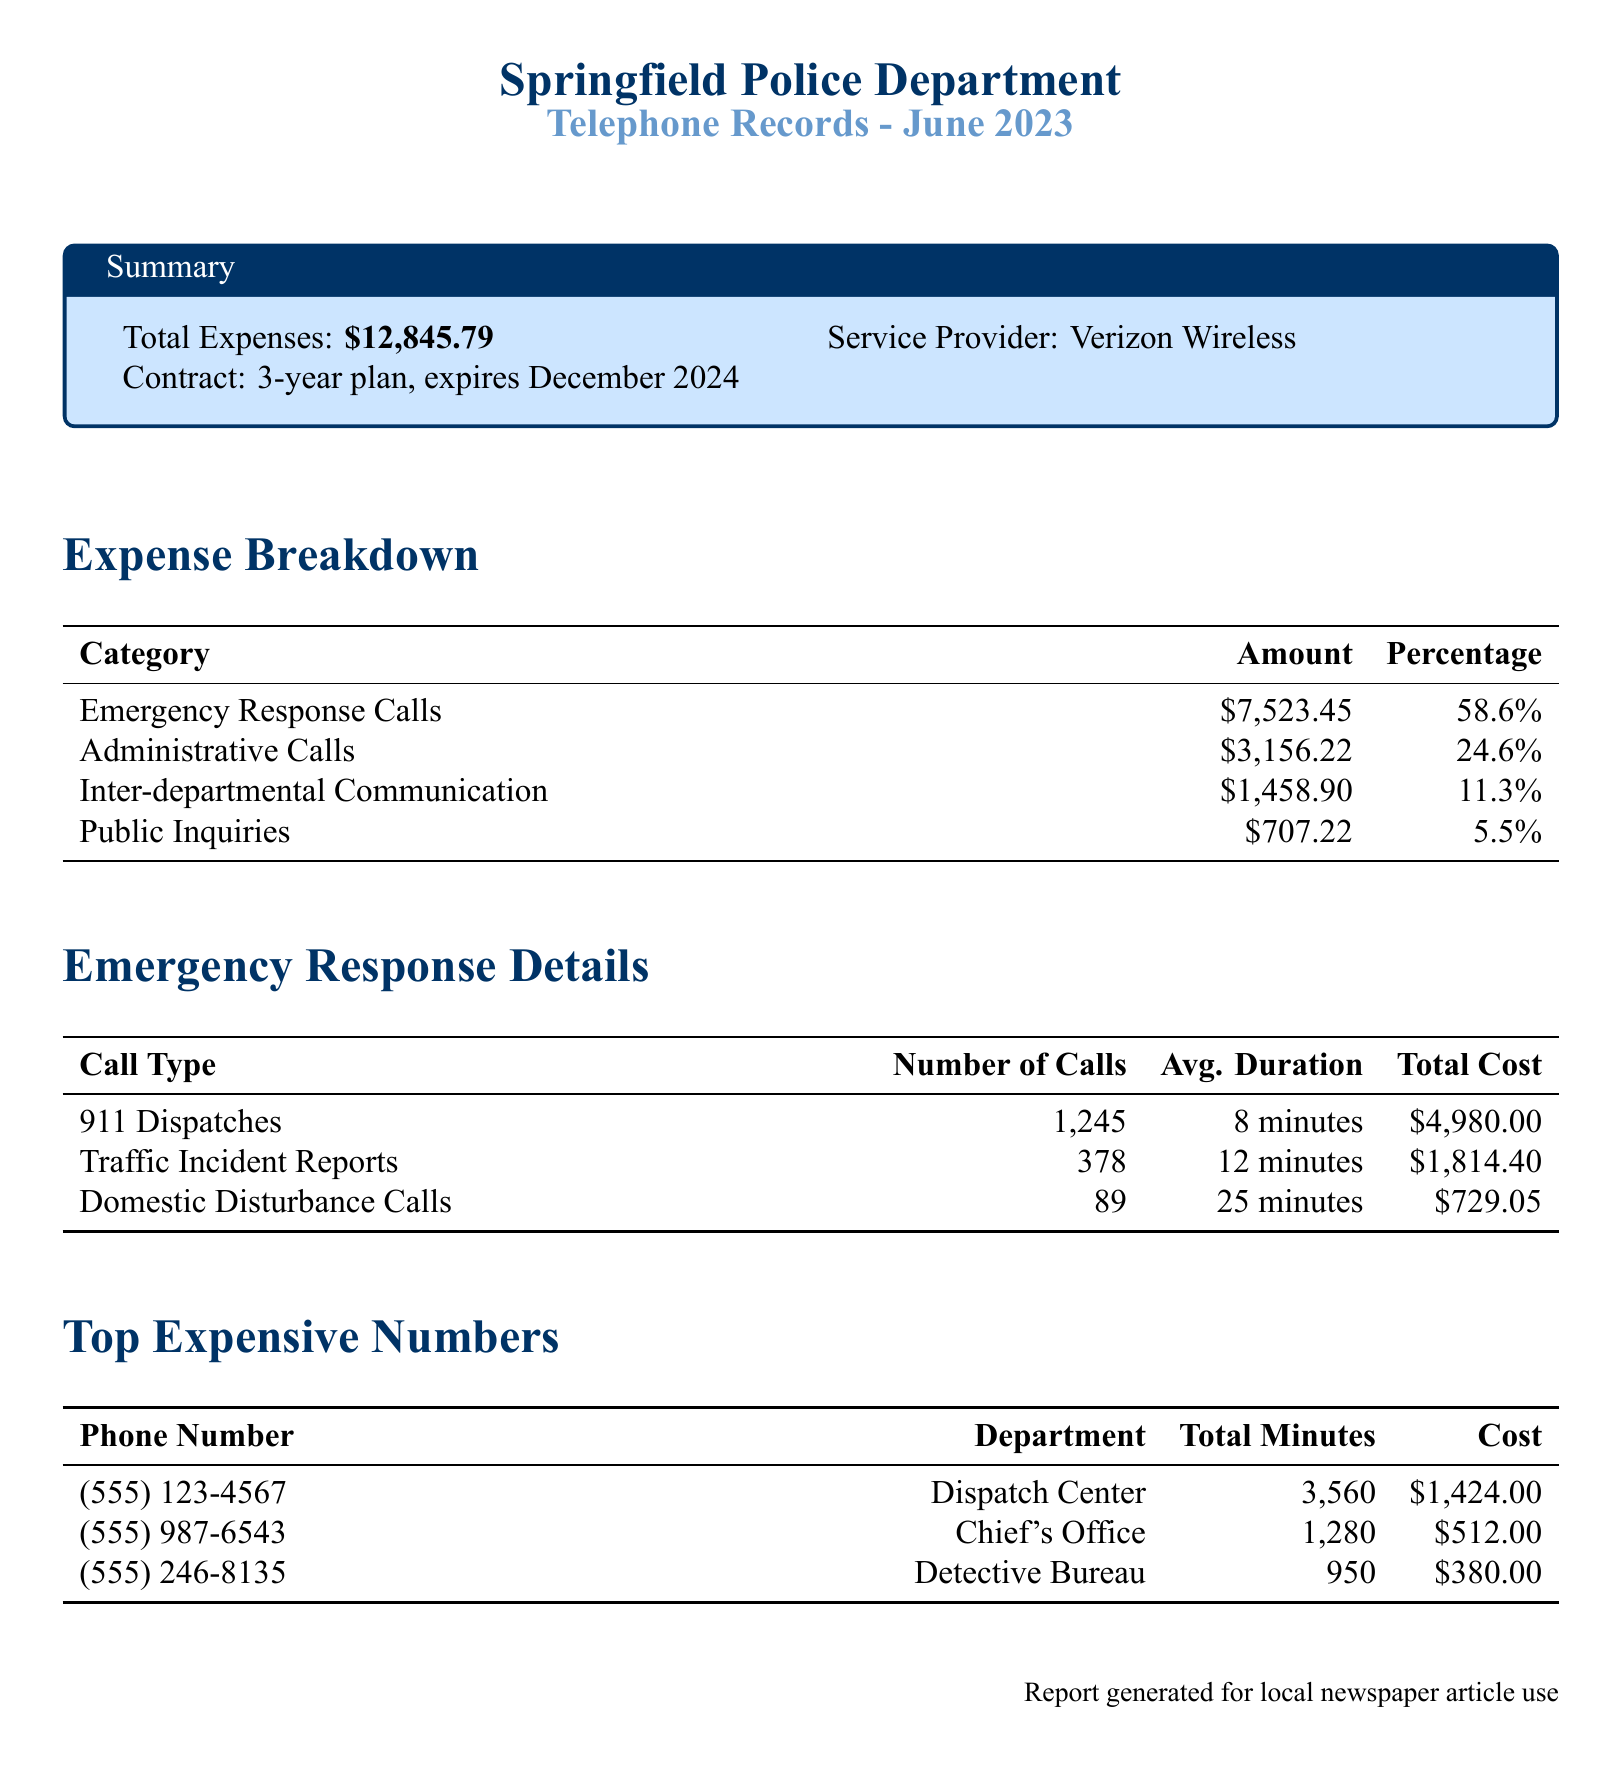What is the total expense for the month? The total expense is listed in the summary section, which is $12,845.79.
Answer: $12,845.79 What percentage of the total expenses are from emergency response calls? The percentage for emergency response calls is calculated in the expense breakdown, which states 58.6%.
Answer: 58.6% How many 911 dispatches were recorded? The number of 911 dispatches is provided in the emergency response details, which is 1,245 calls.
Answer: 1,245 What was the average duration of a traffic incident report call? The average duration for traffic incident report calls is mentioned in the emergency response details, which is 12 minutes.
Answer: 12 minutes Which department had the highest phone cost? The department with the highest phone cost can be identified from the top expensive numbers table, which is the Dispatch Center.
Answer: Dispatch Center What is the total cost for domestic disturbance calls? The total cost for domestic disturbance calls is detailed in the emergency response details, which is $729.05.
Answer: $729.05 What is the service provider for the police department's telephone records? The service provider is listed in the summary section, which is Verizon Wireless.
Answer: Verizon Wireless How many administrative calls were made? The total amount of administrative calls can be found in the expense breakdown, which states $3,156.22.
Answer: $3,156.22 What is the contract expiration date? The contract expiration date is specified in the summary section, which is December 2024.
Answer: December 2024 